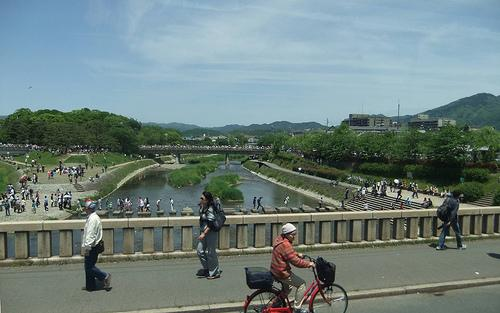What are the people doing in the image for a multi-choice VQA task? People are crossing the water, walking on cement steps, and gathering in a crowd. For the visual entailment task, what can you infer about the landscape in the image? The landscape features water, bridges, trees, buildings, and a distant mountain range. In a visual entailment task, what might you infer about the person wearing a hat? The person wearing a hat may be outdoors or dressed casually. What is the central activity taking place in the image? People are walking across a water bridge, crossing the water using cement steps. In the multi-choice VQA task, tell me a prominent feature of the bridge. The bridge is made of cement and is relatively low, allowing easy access across the water. 